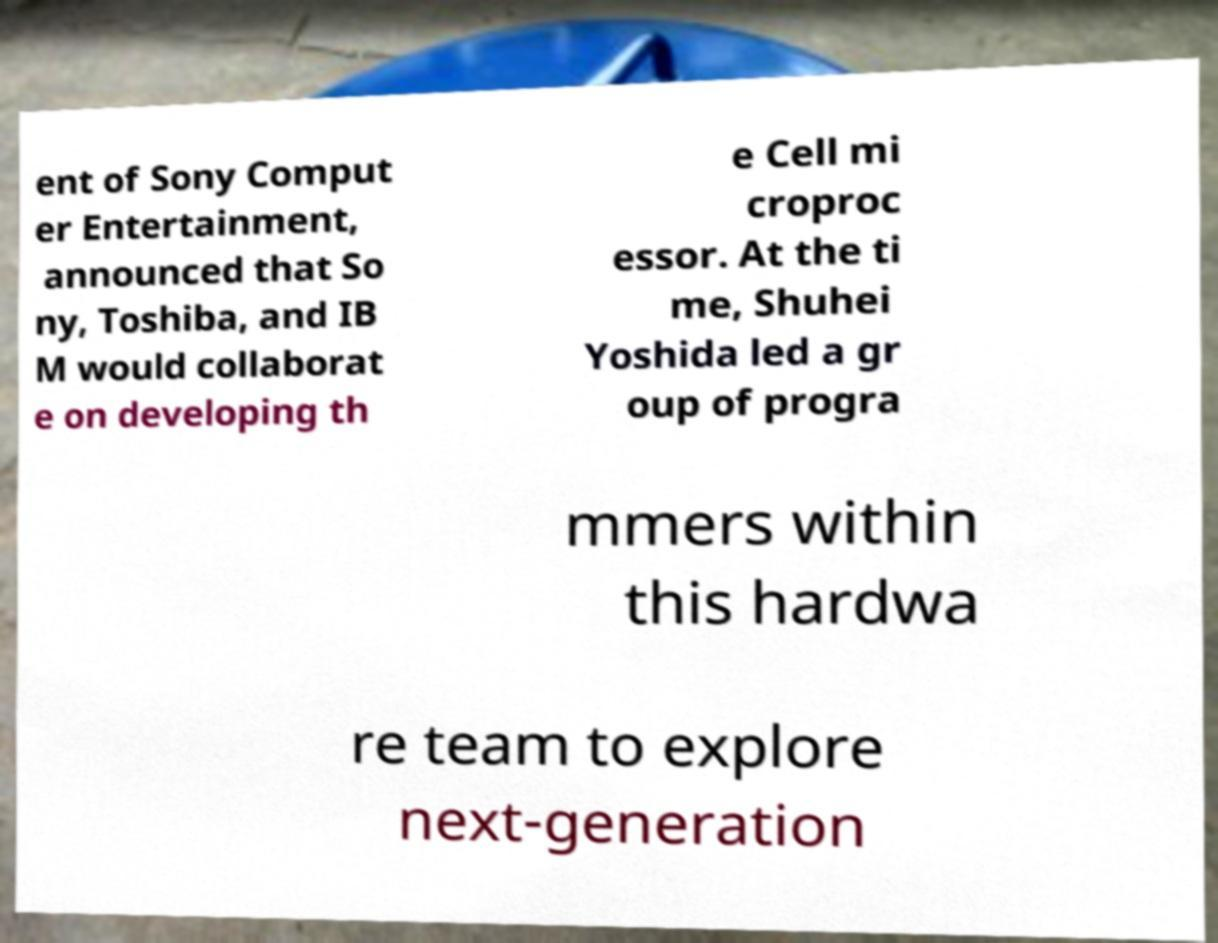What messages or text are displayed in this image? I need them in a readable, typed format. ent of Sony Comput er Entertainment, announced that So ny, Toshiba, and IB M would collaborat e on developing th e Cell mi croproc essor. At the ti me, Shuhei Yoshida led a gr oup of progra mmers within this hardwa re team to explore next-generation 